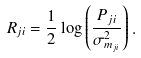Convert formula to latex. <formula><loc_0><loc_0><loc_500><loc_500>R _ { j i } = \frac { 1 } { 2 } \log \left ( \frac { P _ { j i } } { \sigma _ { m _ { j i } } ^ { 2 } } \right ) .</formula> 